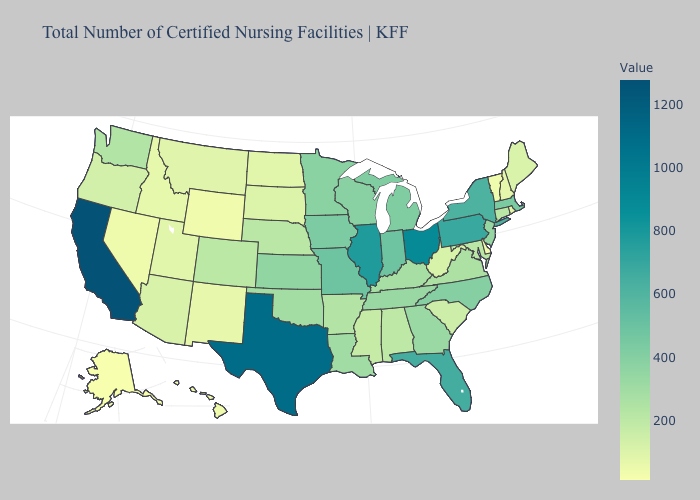Does the map have missing data?
Short answer required. No. Which states have the lowest value in the USA?
Give a very brief answer. Alaska. Among the states that border Tennessee , which have the highest value?
Be succinct. Missouri. Among the states that border Rhode Island , does Connecticut have the lowest value?
Be succinct. Yes. Among the states that border Alabama , does Florida have the highest value?
Short answer required. Yes. Does Texas have the lowest value in the South?
Short answer required. No. Among the states that border Ohio , does Indiana have the lowest value?
Keep it brief. No. Among the states that border Iowa , does Illinois have the highest value?
Be succinct. Yes. Among the states that border Maine , which have the lowest value?
Write a very short answer. New Hampshire. 